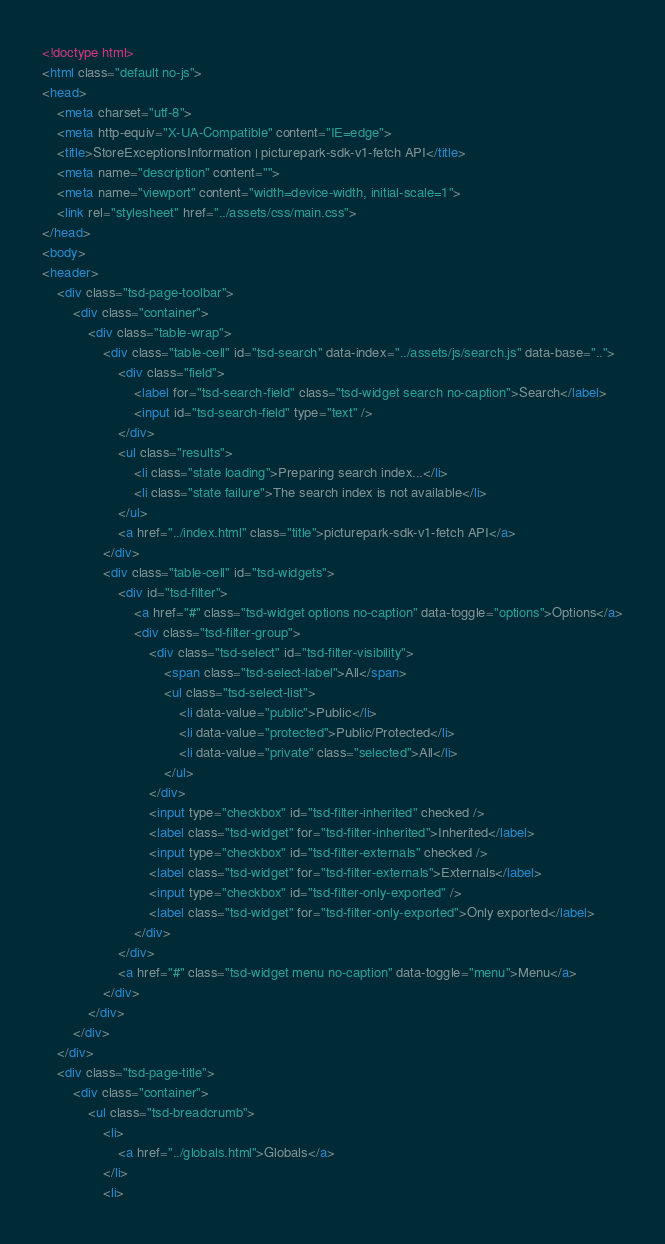Convert code to text. <code><loc_0><loc_0><loc_500><loc_500><_HTML_><!doctype html>
<html class="default no-js">
<head>
	<meta charset="utf-8">
	<meta http-equiv="X-UA-Compatible" content="IE=edge">
	<title>StoreExceptionsInformation | picturepark-sdk-v1-fetch API</title>
	<meta name="description" content="">
	<meta name="viewport" content="width=device-width, initial-scale=1">
	<link rel="stylesheet" href="../assets/css/main.css">
</head>
<body>
<header>
	<div class="tsd-page-toolbar">
		<div class="container">
			<div class="table-wrap">
				<div class="table-cell" id="tsd-search" data-index="../assets/js/search.js" data-base="..">
					<div class="field">
						<label for="tsd-search-field" class="tsd-widget search no-caption">Search</label>
						<input id="tsd-search-field" type="text" />
					</div>
					<ul class="results">
						<li class="state loading">Preparing search index...</li>
						<li class="state failure">The search index is not available</li>
					</ul>
					<a href="../index.html" class="title">picturepark-sdk-v1-fetch API</a>
				</div>
				<div class="table-cell" id="tsd-widgets">
					<div id="tsd-filter">
						<a href="#" class="tsd-widget options no-caption" data-toggle="options">Options</a>
						<div class="tsd-filter-group">
							<div class="tsd-select" id="tsd-filter-visibility">
								<span class="tsd-select-label">All</span>
								<ul class="tsd-select-list">
									<li data-value="public">Public</li>
									<li data-value="protected">Public/Protected</li>
									<li data-value="private" class="selected">All</li>
								</ul>
							</div>
							<input type="checkbox" id="tsd-filter-inherited" checked />
							<label class="tsd-widget" for="tsd-filter-inherited">Inherited</label>
							<input type="checkbox" id="tsd-filter-externals" checked />
							<label class="tsd-widget" for="tsd-filter-externals">Externals</label>
							<input type="checkbox" id="tsd-filter-only-exported" />
							<label class="tsd-widget" for="tsd-filter-only-exported">Only exported</label>
						</div>
					</div>
					<a href="#" class="tsd-widget menu no-caption" data-toggle="menu">Menu</a>
				</div>
			</div>
		</div>
	</div>
	<div class="tsd-page-title">
		<div class="container">
			<ul class="tsd-breadcrumb">
				<li>
					<a href="../globals.html">Globals</a>
				</li>
				<li></code> 